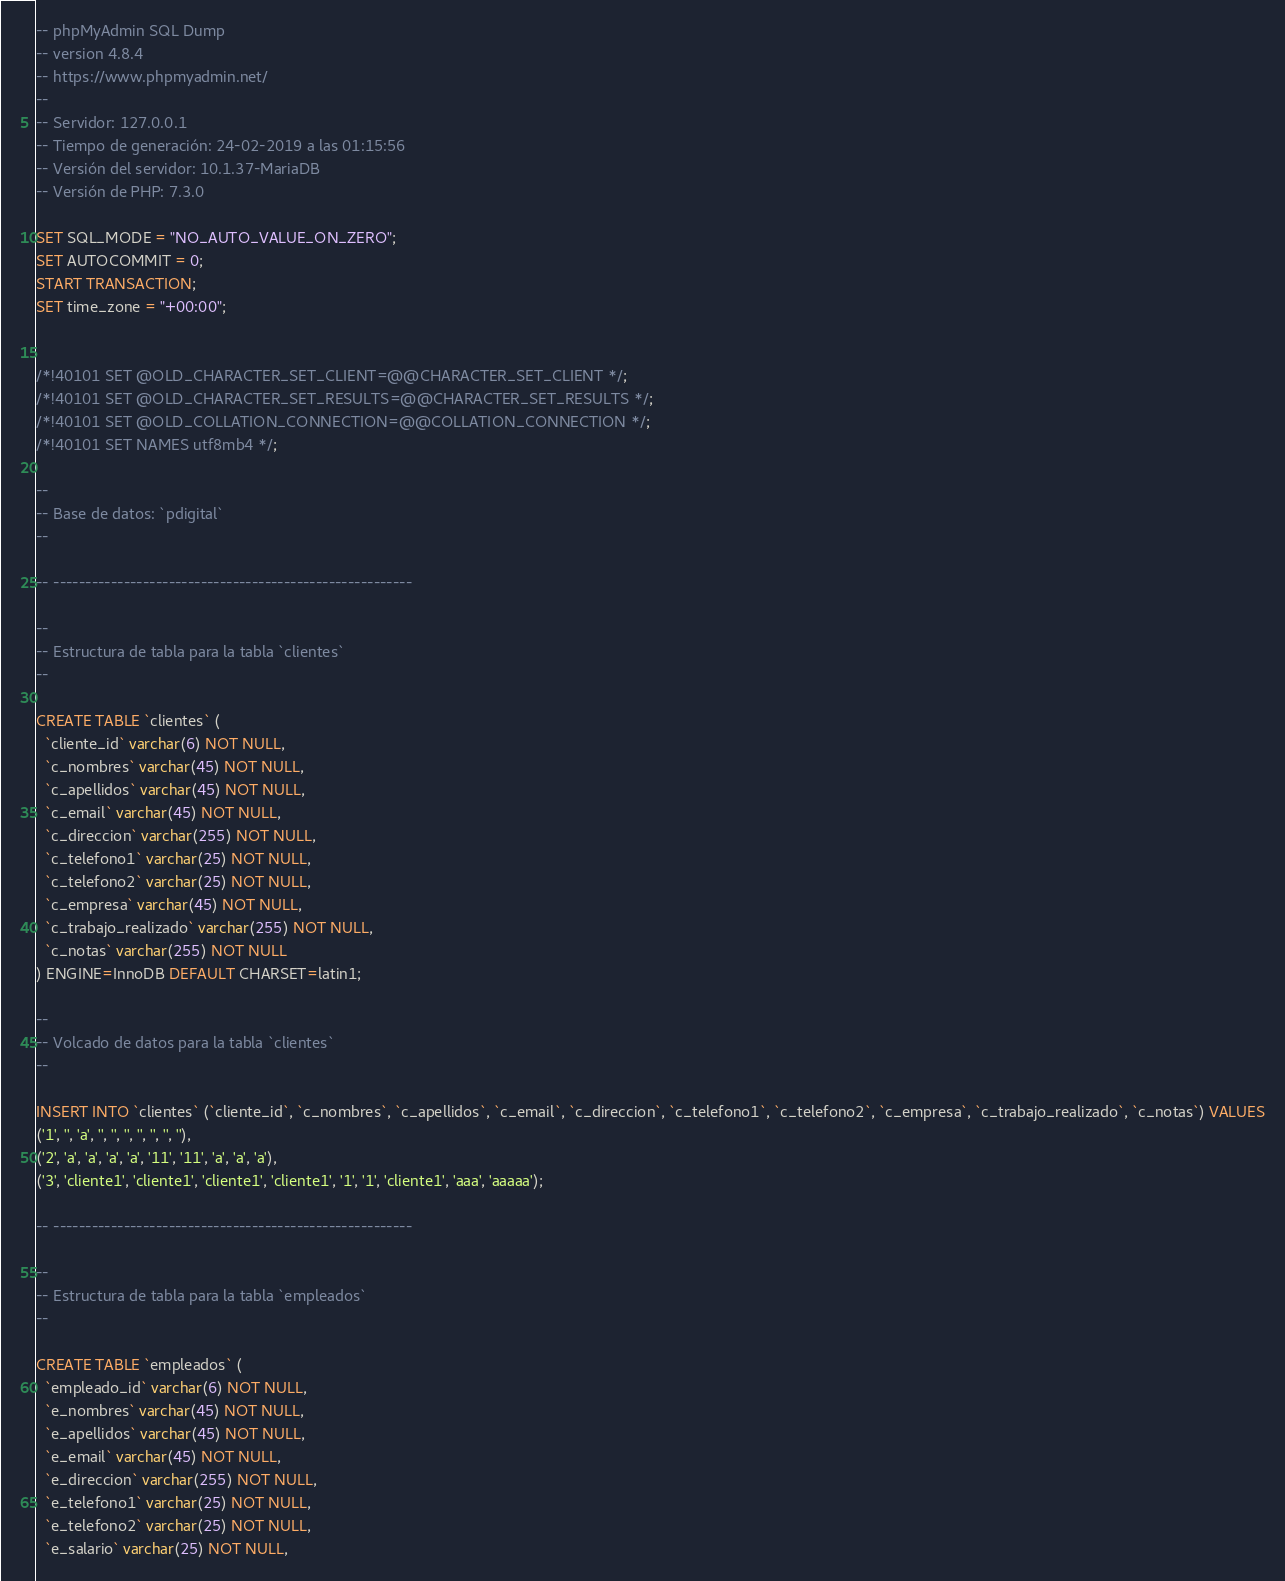Convert code to text. <code><loc_0><loc_0><loc_500><loc_500><_SQL_>-- phpMyAdmin SQL Dump
-- version 4.8.4
-- https://www.phpmyadmin.net/
--
-- Servidor: 127.0.0.1
-- Tiempo de generación: 24-02-2019 a las 01:15:56
-- Versión del servidor: 10.1.37-MariaDB
-- Versión de PHP: 7.3.0

SET SQL_MODE = "NO_AUTO_VALUE_ON_ZERO";
SET AUTOCOMMIT = 0;
START TRANSACTION;
SET time_zone = "+00:00";


/*!40101 SET @OLD_CHARACTER_SET_CLIENT=@@CHARACTER_SET_CLIENT */;
/*!40101 SET @OLD_CHARACTER_SET_RESULTS=@@CHARACTER_SET_RESULTS */;
/*!40101 SET @OLD_COLLATION_CONNECTION=@@COLLATION_CONNECTION */;
/*!40101 SET NAMES utf8mb4 */;

--
-- Base de datos: `pdigital`
--

-- --------------------------------------------------------

--
-- Estructura de tabla para la tabla `clientes`
--

CREATE TABLE `clientes` (
  `cliente_id` varchar(6) NOT NULL,
  `c_nombres` varchar(45) NOT NULL,
  `c_apellidos` varchar(45) NOT NULL,
  `c_email` varchar(45) NOT NULL,
  `c_direccion` varchar(255) NOT NULL,
  `c_telefono1` varchar(25) NOT NULL,
  `c_telefono2` varchar(25) NOT NULL,
  `c_empresa` varchar(45) NOT NULL,
  `c_trabajo_realizado` varchar(255) NOT NULL,
  `c_notas` varchar(255) NOT NULL
) ENGINE=InnoDB DEFAULT CHARSET=latin1;

--
-- Volcado de datos para la tabla `clientes`
--

INSERT INTO `clientes` (`cliente_id`, `c_nombres`, `c_apellidos`, `c_email`, `c_direccion`, `c_telefono1`, `c_telefono2`, `c_empresa`, `c_trabajo_realizado`, `c_notas`) VALUES
('1', '', 'a', '', '', '', '', '', '', ''),
('2', 'a', 'a', 'a', 'a', '11', '11', 'a', 'a', 'a'),
('3', 'cliente1', 'cliente1', 'cliente1', 'cliente1', '1', '1', 'cliente1', 'aaa', 'aaaaa');

-- --------------------------------------------------------

--
-- Estructura de tabla para la tabla `empleados`
--

CREATE TABLE `empleados` (
  `empleado_id` varchar(6) NOT NULL,
  `e_nombres` varchar(45) NOT NULL,
  `e_apellidos` varchar(45) NOT NULL,
  `e_email` varchar(45) NOT NULL,
  `e_direccion` varchar(255) NOT NULL,
  `e_telefono1` varchar(25) NOT NULL,
  `e_telefono2` varchar(25) NOT NULL,
  `e_salario` varchar(25) NOT NULL,</code> 